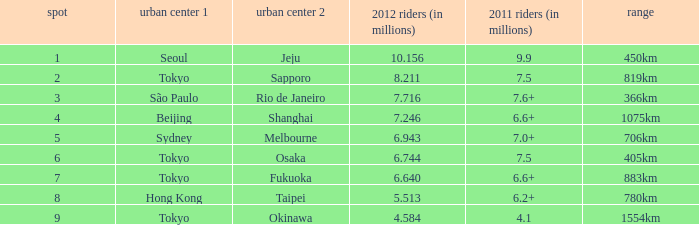In 2011, which city is listed first along the route that had 7.6+ million passengers? São Paulo. 